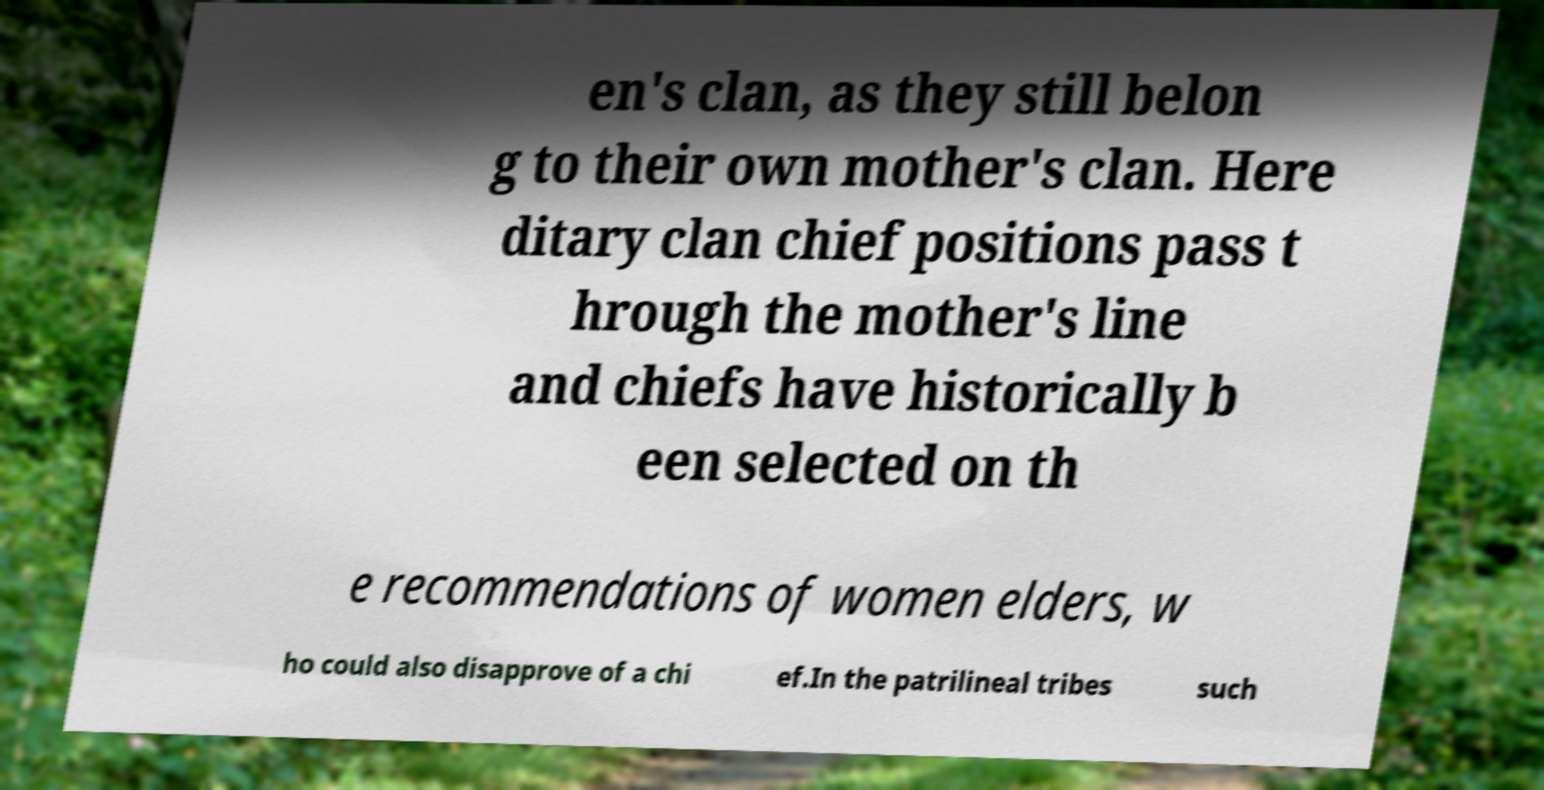Could you extract and type out the text from this image? en's clan, as they still belon g to their own mother's clan. Here ditary clan chief positions pass t hrough the mother's line and chiefs have historically b een selected on th e recommendations of women elders, w ho could also disapprove of a chi ef.In the patrilineal tribes such 